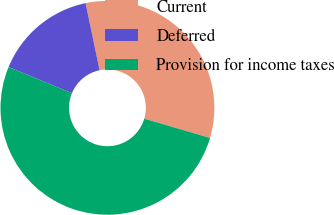Convert chart to OTSL. <chart><loc_0><loc_0><loc_500><loc_500><pie_chart><fcel>Current<fcel>Deferred<fcel>Provision for income taxes<nl><fcel>32.83%<fcel>15.5%<fcel>51.67%<nl></chart> 